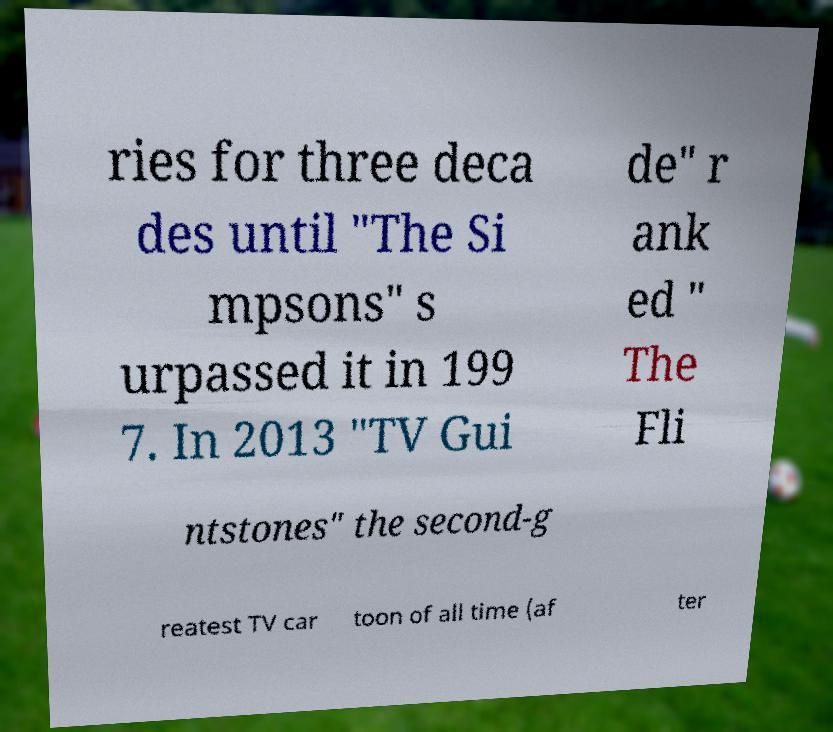What messages or text are displayed in this image? I need them in a readable, typed format. ries for three deca des until "The Si mpsons" s urpassed it in 199 7. In 2013 "TV Gui de" r ank ed " The Fli ntstones" the second-g reatest TV car toon of all time (af ter 